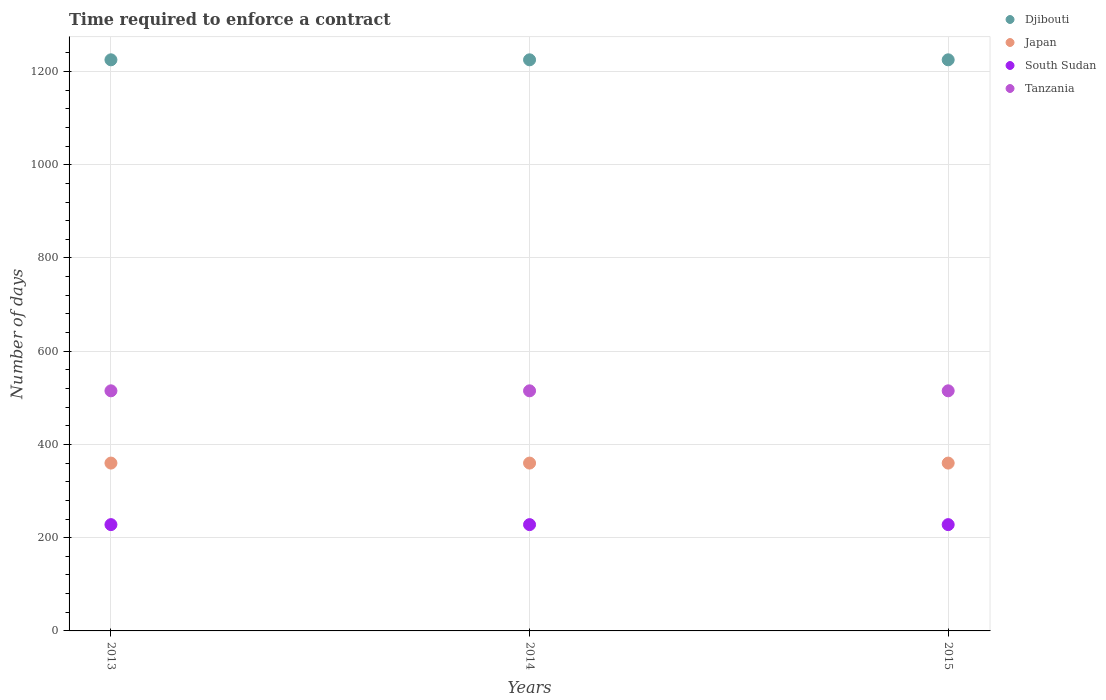Is the number of dotlines equal to the number of legend labels?
Your answer should be very brief. Yes. What is the number of days required to enforce a contract in Japan in 2014?
Offer a very short reply. 360. Across all years, what is the maximum number of days required to enforce a contract in South Sudan?
Offer a terse response. 228. Across all years, what is the minimum number of days required to enforce a contract in Tanzania?
Offer a very short reply. 515. What is the total number of days required to enforce a contract in Djibouti in the graph?
Your answer should be compact. 3675. What is the difference between the number of days required to enforce a contract in Tanzania in 2013 and that in 2014?
Your answer should be very brief. 0. What is the difference between the number of days required to enforce a contract in Tanzania in 2013 and the number of days required to enforce a contract in Djibouti in 2014?
Make the answer very short. -710. What is the average number of days required to enforce a contract in Japan per year?
Provide a succinct answer. 360. In the year 2014, what is the difference between the number of days required to enforce a contract in South Sudan and number of days required to enforce a contract in Japan?
Your answer should be very brief. -132. In how many years, is the number of days required to enforce a contract in Japan greater than 880 days?
Ensure brevity in your answer.  0. Is the number of days required to enforce a contract in Tanzania in 2014 less than that in 2015?
Offer a terse response. No. What is the difference between the highest and the second highest number of days required to enforce a contract in South Sudan?
Provide a succinct answer. 0. What is the difference between the highest and the lowest number of days required to enforce a contract in Djibouti?
Offer a very short reply. 0. Is it the case that in every year, the sum of the number of days required to enforce a contract in Japan and number of days required to enforce a contract in South Sudan  is greater than the number of days required to enforce a contract in Tanzania?
Provide a short and direct response. Yes. Is the number of days required to enforce a contract in Japan strictly less than the number of days required to enforce a contract in Djibouti over the years?
Your answer should be very brief. Yes. How many dotlines are there?
Your answer should be very brief. 4. What is the difference between two consecutive major ticks on the Y-axis?
Make the answer very short. 200. Does the graph contain any zero values?
Provide a succinct answer. No. What is the title of the graph?
Provide a succinct answer. Time required to enforce a contract. What is the label or title of the Y-axis?
Offer a very short reply. Number of days. What is the Number of days of Djibouti in 2013?
Make the answer very short. 1225. What is the Number of days in Japan in 2013?
Provide a short and direct response. 360. What is the Number of days of South Sudan in 2013?
Offer a terse response. 228. What is the Number of days of Tanzania in 2013?
Provide a succinct answer. 515. What is the Number of days of Djibouti in 2014?
Your answer should be very brief. 1225. What is the Number of days in Japan in 2014?
Give a very brief answer. 360. What is the Number of days of South Sudan in 2014?
Offer a terse response. 228. What is the Number of days in Tanzania in 2014?
Ensure brevity in your answer.  515. What is the Number of days of Djibouti in 2015?
Give a very brief answer. 1225. What is the Number of days of Japan in 2015?
Offer a very short reply. 360. What is the Number of days in South Sudan in 2015?
Make the answer very short. 228. What is the Number of days in Tanzania in 2015?
Offer a very short reply. 515. Across all years, what is the maximum Number of days in Djibouti?
Provide a short and direct response. 1225. Across all years, what is the maximum Number of days of Japan?
Offer a very short reply. 360. Across all years, what is the maximum Number of days in South Sudan?
Provide a succinct answer. 228. Across all years, what is the maximum Number of days in Tanzania?
Offer a terse response. 515. Across all years, what is the minimum Number of days in Djibouti?
Offer a terse response. 1225. Across all years, what is the minimum Number of days in Japan?
Offer a very short reply. 360. Across all years, what is the minimum Number of days in South Sudan?
Make the answer very short. 228. Across all years, what is the minimum Number of days in Tanzania?
Your answer should be very brief. 515. What is the total Number of days of Djibouti in the graph?
Make the answer very short. 3675. What is the total Number of days in Japan in the graph?
Your answer should be very brief. 1080. What is the total Number of days in South Sudan in the graph?
Make the answer very short. 684. What is the total Number of days of Tanzania in the graph?
Give a very brief answer. 1545. What is the difference between the Number of days of Japan in 2013 and that in 2014?
Keep it short and to the point. 0. What is the difference between the Number of days of South Sudan in 2013 and that in 2014?
Your answer should be very brief. 0. What is the difference between the Number of days in Tanzania in 2013 and that in 2014?
Ensure brevity in your answer.  0. What is the difference between the Number of days in Tanzania in 2013 and that in 2015?
Offer a terse response. 0. What is the difference between the Number of days of Japan in 2014 and that in 2015?
Offer a very short reply. 0. What is the difference between the Number of days of Tanzania in 2014 and that in 2015?
Offer a terse response. 0. What is the difference between the Number of days of Djibouti in 2013 and the Number of days of Japan in 2014?
Offer a terse response. 865. What is the difference between the Number of days of Djibouti in 2013 and the Number of days of South Sudan in 2014?
Your answer should be compact. 997. What is the difference between the Number of days in Djibouti in 2013 and the Number of days in Tanzania in 2014?
Make the answer very short. 710. What is the difference between the Number of days of Japan in 2013 and the Number of days of South Sudan in 2014?
Your response must be concise. 132. What is the difference between the Number of days in Japan in 2013 and the Number of days in Tanzania in 2014?
Provide a short and direct response. -155. What is the difference between the Number of days of South Sudan in 2013 and the Number of days of Tanzania in 2014?
Your answer should be very brief. -287. What is the difference between the Number of days in Djibouti in 2013 and the Number of days in Japan in 2015?
Ensure brevity in your answer.  865. What is the difference between the Number of days of Djibouti in 2013 and the Number of days of South Sudan in 2015?
Ensure brevity in your answer.  997. What is the difference between the Number of days of Djibouti in 2013 and the Number of days of Tanzania in 2015?
Offer a terse response. 710. What is the difference between the Number of days of Japan in 2013 and the Number of days of South Sudan in 2015?
Your answer should be very brief. 132. What is the difference between the Number of days of Japan in 2013 and the Number of days of Tanzania in 2015?
Ensure brevity in your answer.  -155. What is the difference between the Number of days of South Sudan in 2013 and the Number of days of Tanzania in 2015?
Provide a short and direct response. -287. What is the difference between the Number of days of Djibouti in 2014 and the Number of days of Japan in 2015?
Ensure brevity in your answer.  865. What is the difference between the Number of days in Djibouti in 2014 and the Number of days in South Sudan in 2015?
Ensure brevity in your answer.  997. What is the difference between the Number of days in Djibouti in 2014 and the Number of days in Tanzania in 2015?
Your answer should be very brief. 710. What is the difference between the Number of days in Japan in 2014 and the Number of days in South Sudan in 2015?
Offer a very short reply. 132. What is the difference between the Number of days in Japan in 2014 and the Number of days in Tanzania in 2015?
Your answer should be compact. -155. What is the difference between the Number of days in South Sudan in 2014 and the Number of days in Tanzania in 2015?
Ensure brevity in your answer.  -287. What is the average Number of days in Djibouti per year?
Your answer should be compact. 1225. What is the average Number of days of Japan per year?
Provide a short and direct response. 360. What is the average Number of days in South Sudan per year?
Make the answer very short. 228. What is the average Number of days in Tanzania per year?
Your answer should be compact. 515. In the year 2013, what is the difference between the Number of days of Djibouti and Number of days of Japan?
Your answer should be compact. 865. In the year 2013, what is the difference between the Number of days in Djibouti and Number of days in South Sudan?
Your answer should be very brief. 997. In the year 2013, what is the difference between the Number of days in Djibouti and Number of days in Tanzania?
Your answer should be compact. 710. In the year 2013, what is the difference between the Number of days of Japan and Number of days of South Sudan?
Offer a terse response. 132. In the year 2013, what is the difference between the Number of days in Japan and Number of days in Tanzania?
Offer a very short reply. -155. In the year 2013, what is the difference between the Number of days in South Sudan and Number of days in Tanzania?
Offer a terse response. -287. In the year 2014, what is the difference between the Number of days of Djibouti and Number of days of Japan?
Keep it short and to the point. 865. In the year 2014, what is the difference between the Number of days in Djibouti and Number of days in South Sudan?
Keep it short and to the point. 997. In the year 2014, what is the difference between the Number of days of Djibouti and Number of days of Tanzania?
Your response must be concise. 710. In the year 2014, what is the difference between the Number of days in Japan and Number of days in South Sudan?
Give a very brief answer. 132. In the year 2014, what is the difference between the Number of days of Japan and Number of days of Tanzania?
Offer a very short reply. -155. In the year 2014, what is the difference between the Number of days of South Sudan and Number of days of Tanzania?
Provide a succinct answer. -287. In the year 2015, what is the difference between the Number of days in Djibouti and Number of days in Japan?
Offer a very short reply. 865. In the year 2015, what is the difference between the Number of days in Djibouti and Number of days in South Sudan?
Offer a terse response. 997. In the year 2015, what is the difference between the Number of days in Djibouti and Number of days in Tanzania?
Make the answer very short. 710. In the year 2015, what is the difference between the Number of days of Japan and Number of days of South Sudan?
Provide a succinct answer. 132. In the year 2015, what is the difference between the Number of days in Japan and Number of days in Tanzania?
Make the answer very short. -155. In the year 2015, what is the difference between the Number of days in South Sudan and Number of days in Tanzania?
Your answer should be very brief. -287. What is the ratio of the Number of days of Djibouti in 2013 to that in 2014?
Your response must be concise. 1. What is the ratio of the Number of days of South Sudan in 2013 to that in 2014?
Your answer should be compact. 1. What is the ratio of the Number of days in Tanzania in 2013 to that in 2014?
Provide a short and direct response. 1. What is the ratio of the Number of days in South Sudan in 2013 to that in 2015?
Make the answer very short. 1. What is the ratio of the Number of days in Tanzania in 2013 to that in 2015?
Your answer should be compact. 1. What is the difference between the highest and the second highest Number of days of South Sudan?
Your response must be concise. 0. What is the difference between the highest and the second highest Number of days of Tanzania?
Offer a terse response. 0. What is the difference between the highest and the lowest Number of days of South Sudan?
Offer a terse response. 0. What is the difference between the highest and the lowest Number of days of Tanzania?
Ensure brevity in your answer.  0. 